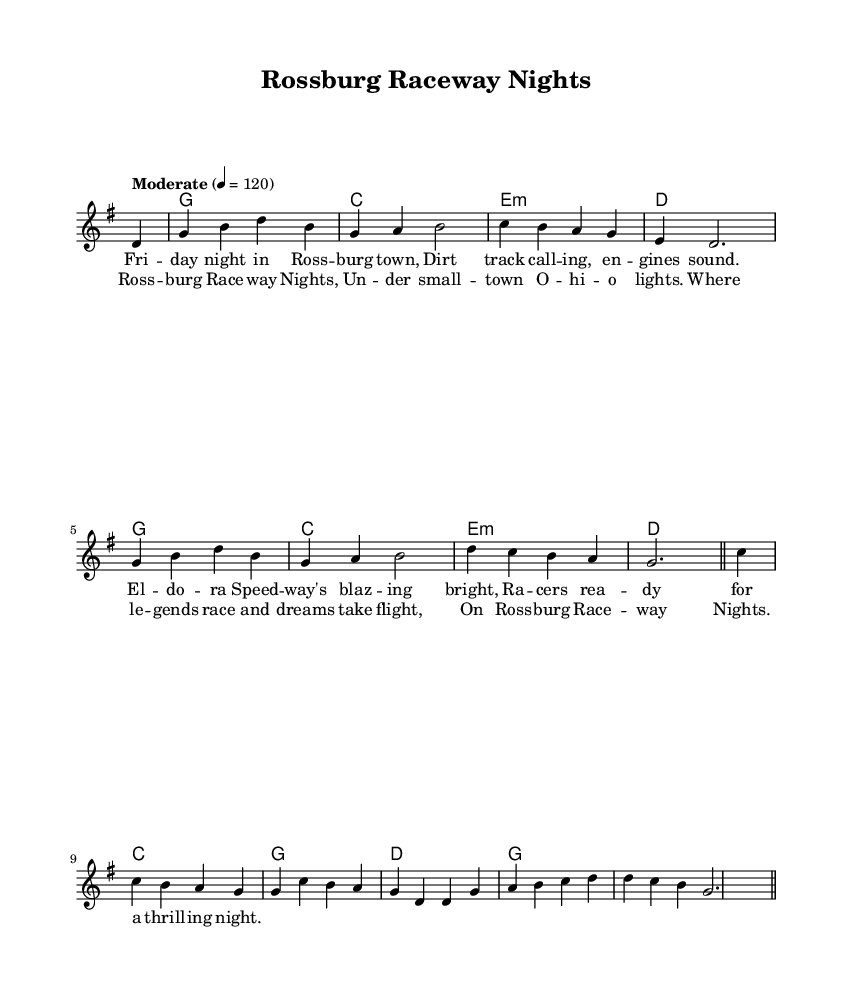What is the key signature of this music? The key signature is G major, which has one sharp (F#).
Answer: G major What is the time signature of this music? The time signature indicated is 4/4, meaning there are four beats per measure.
Answer: 4/4 What is the tempo marking for this piece? The tempo marking is indicated as "Moderate" with a tempo of 120 beats per minute.
Answer: Moderate, 120 How many measures are there in the melody section? The melody consists of 8 measures, as counted from the beginning to the last bar line.
Answer: 8 What is the first lyric line of the verse? The first lyric line of the verse is "Friday night in Rossburg town." This is the line directly under the melody.
Answer: Friday night in Rossburg town What musical style does this song represent? This song is categorized as Country Rock, reflecting themes of racing and small-town life in Ohio.
Answer: Country Rock What landmarks are celebrated in the song? The song specifically mentions "Eldora Speedway," indicating it as a key landmark in Rossburg, Ohio.
Answer: Eldora Speedway 